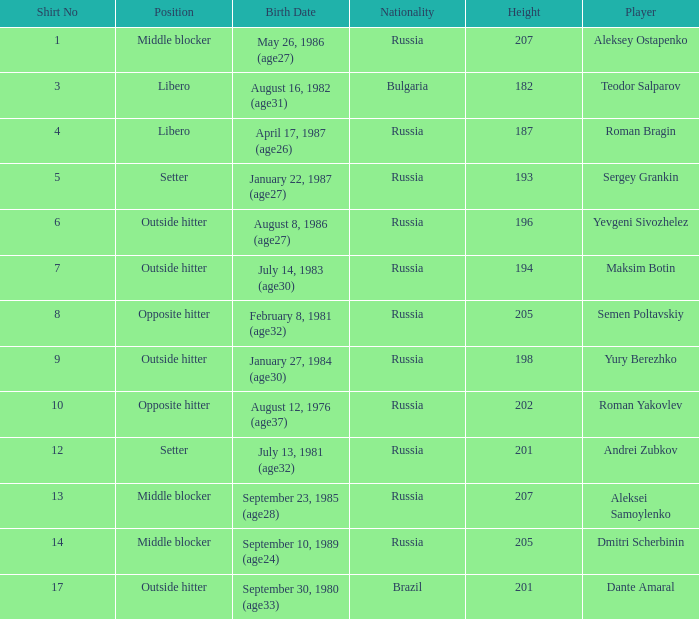What is Maksim Botin's position?  Outside hitter. 